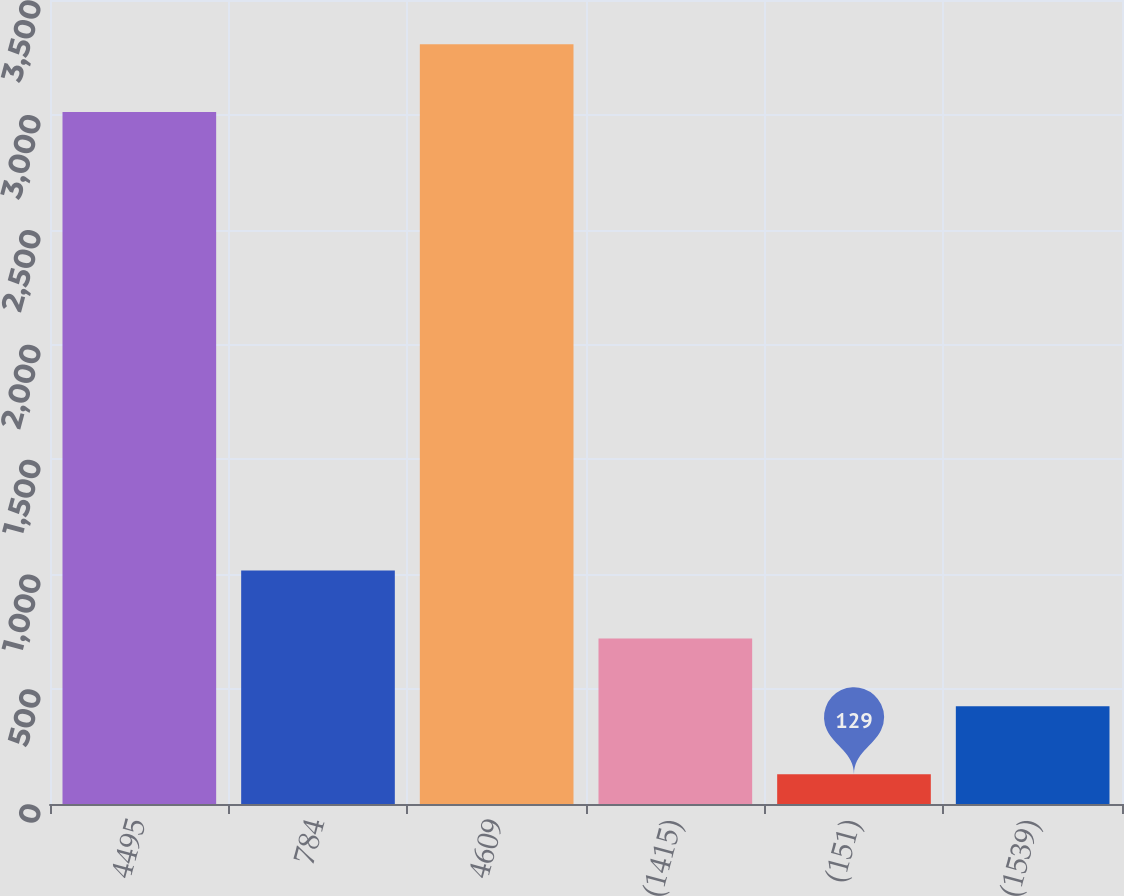Convert chart. <chart><loc_0><loc_0><loc_500><loc_500><bar_chart><fcel>4495<fcel>784<fcel>4609<fcel>(1415)<fcel>(151)<fcel>(1539)<nl><fcel>3012<fcel>1016<fcel>3307.5<fcel>720.5<fcel>129<fcel>425<nl></chart> 